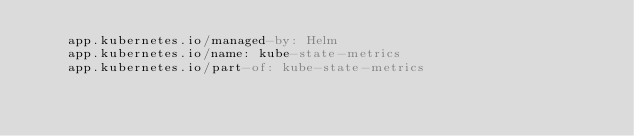<code> <loc_0><loc_0><loc_500><loc_500><_YAML_>    app.kubernetes.io/managed-by: Helm
    app.kubernetes.io/name: kube-state-metrics
    app.kubernetes.io/part-of: kube-state-metrics</code> 